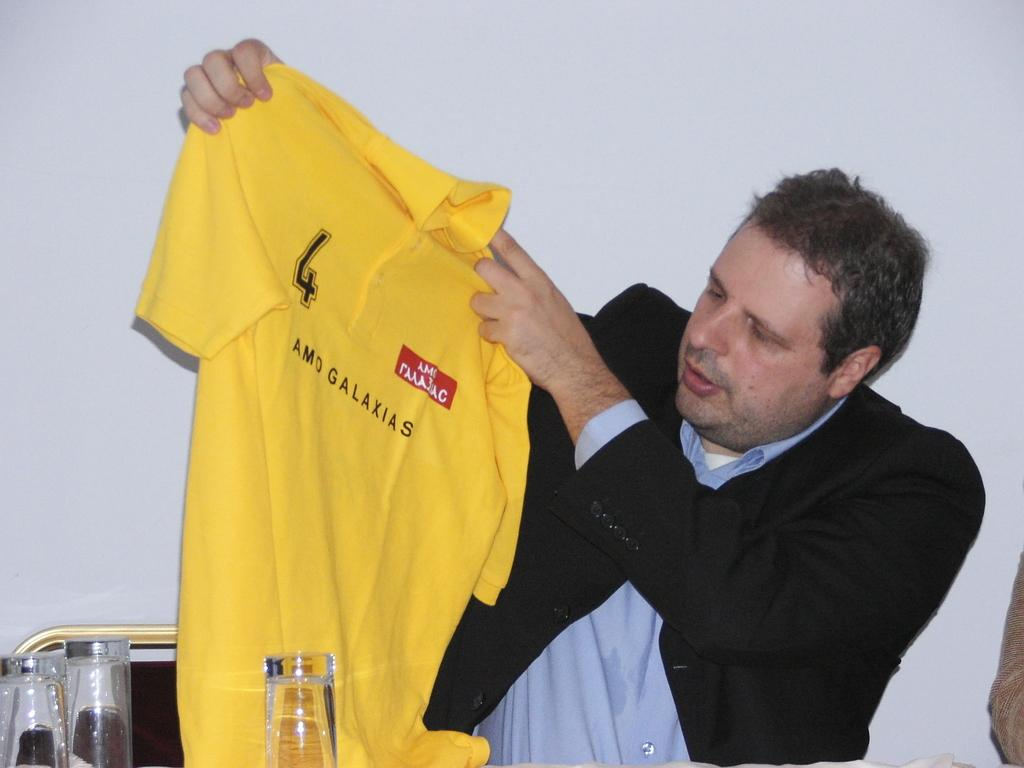<image>
Summarize the visual content of the image. A man holding up a yellow shirt that reads AMO GALAXIAS 